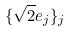Convert formula to latex. <formula><loc_0><loc_0><loc_500><loc_500>\{ \sqrt { 2 } e _ { j } \} _ { j }</formula> 